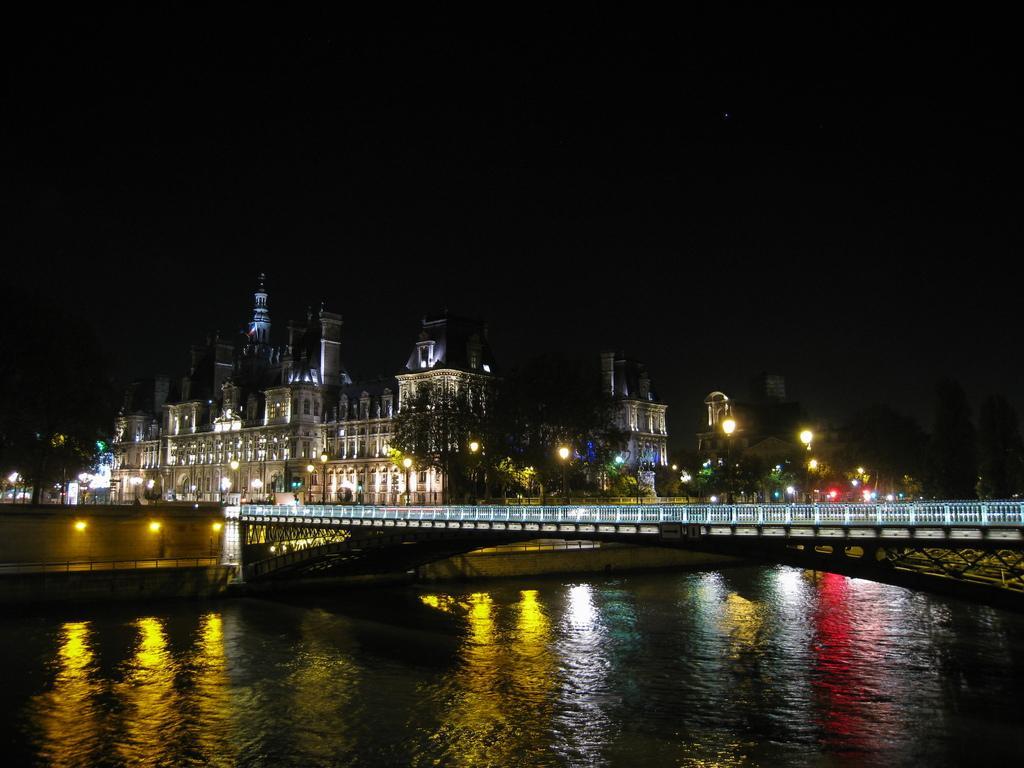How would you summarize this image in a sentence or two? In this image I can see the water, a bridge, the railing on the bridge, few lights and few buildings. In the background I can see the dark sky. 